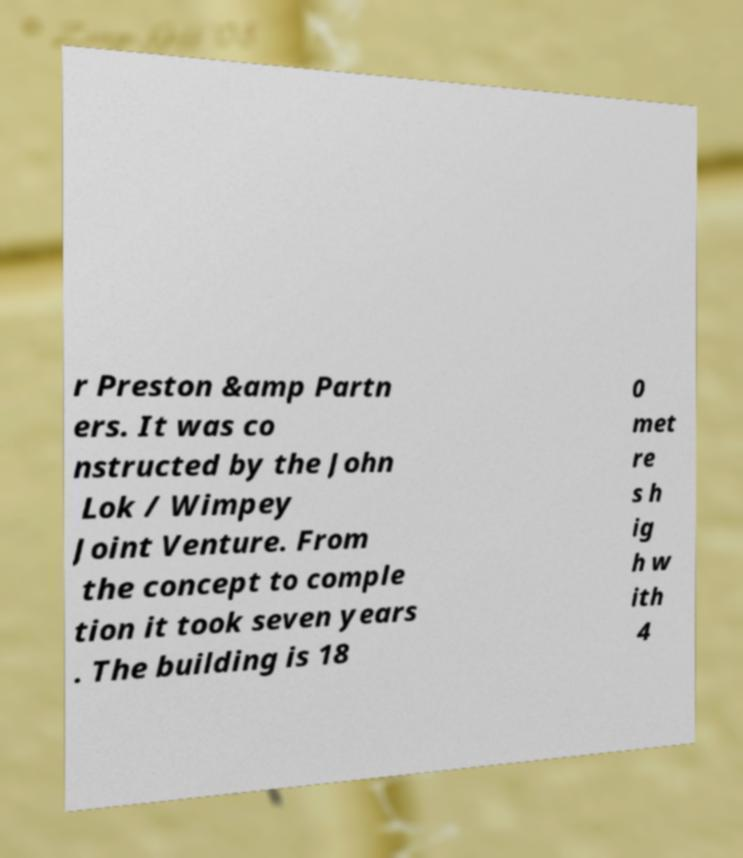I need the written content from this picture converted into text. Can you do that? r Preston &amp Partn ers. It was co nstructed by the John Lok / Wimpey Joint Venture. From the concept to comple tion it took seven years . The building is 18 0 met re s h ig h w ith 4 